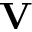Convert formula to latex. <formula><loc_0><loc_0><loc_500><loc_500>V</formula> 